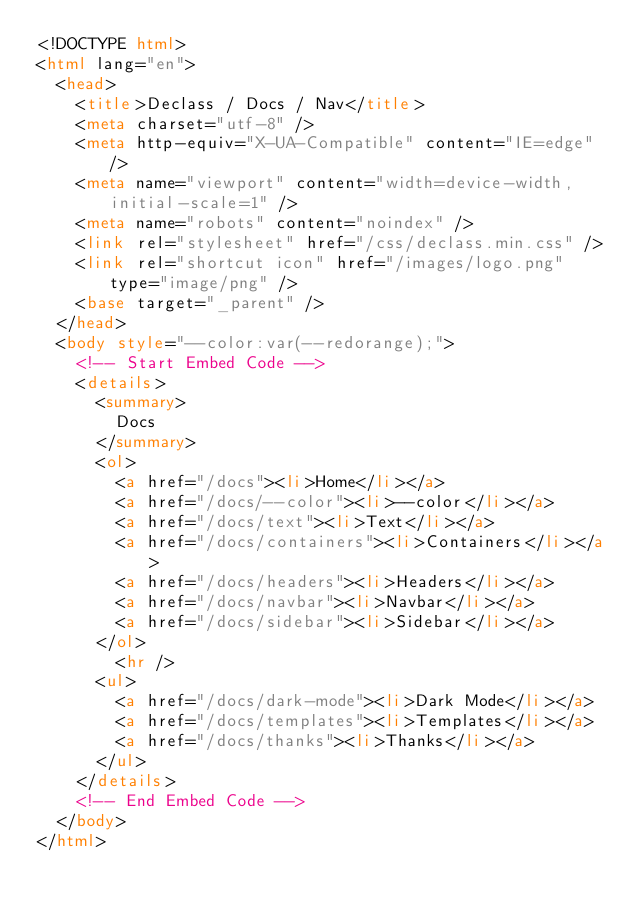Convert code to text. <code><loc_0><loc_0><loc_500><loc_500><_HTML_><!DOCTYPE html>
<html lang="en">
  <head>
    <title>Declass / Docs / Nav</title>
    <meta charset="utf-8" />
    <meta http-equiv="X-UA-Compatible" content="IE=edge" />
    <meta name="viewport" content="width=device-width, initial-scale=1" />
    <meta name="robots" content="noindex" />
    <link rel="stylesheet" href="/css/declass.min.css" />
    <link rel="shortcut icon" href="/images/logo.png" type="image/png" />
    <base target="_parent" />
  </head>
  <body style="--color:var(--redorange);">
    <!-- Start Embed Code -->
    <details>
      <summary>
        Docs
      </summary>
      <ol>
        <a href="/docs"><li>Home</li></a>
        <a href="/docs/--color"><li>--color</li></a>
        <a href="/docs/text"><li>Text</li></a>
        <a href="/docs/containers"><li>Containers</li></a>
        <a href="/docs/headers"><li>Headers</li></a>
        <a href="/docs/navbar"><li>Navbar</li></a>
        <a href="/docs/sidebar"><li>Sidebar</li></a>
      </ol>
        <hr />
      <ul>        
        <a href="/docs/dark-mode"><li>Dark Mode</li></a>
        <a href="/docs/templates"><li>Templates</li></a>
        <a href="/docs/thanks"><li>Thanks</li></a>
      </ul>
    </details>
    <!-- End Embed Code -->
  </body>
</html>
</code> 